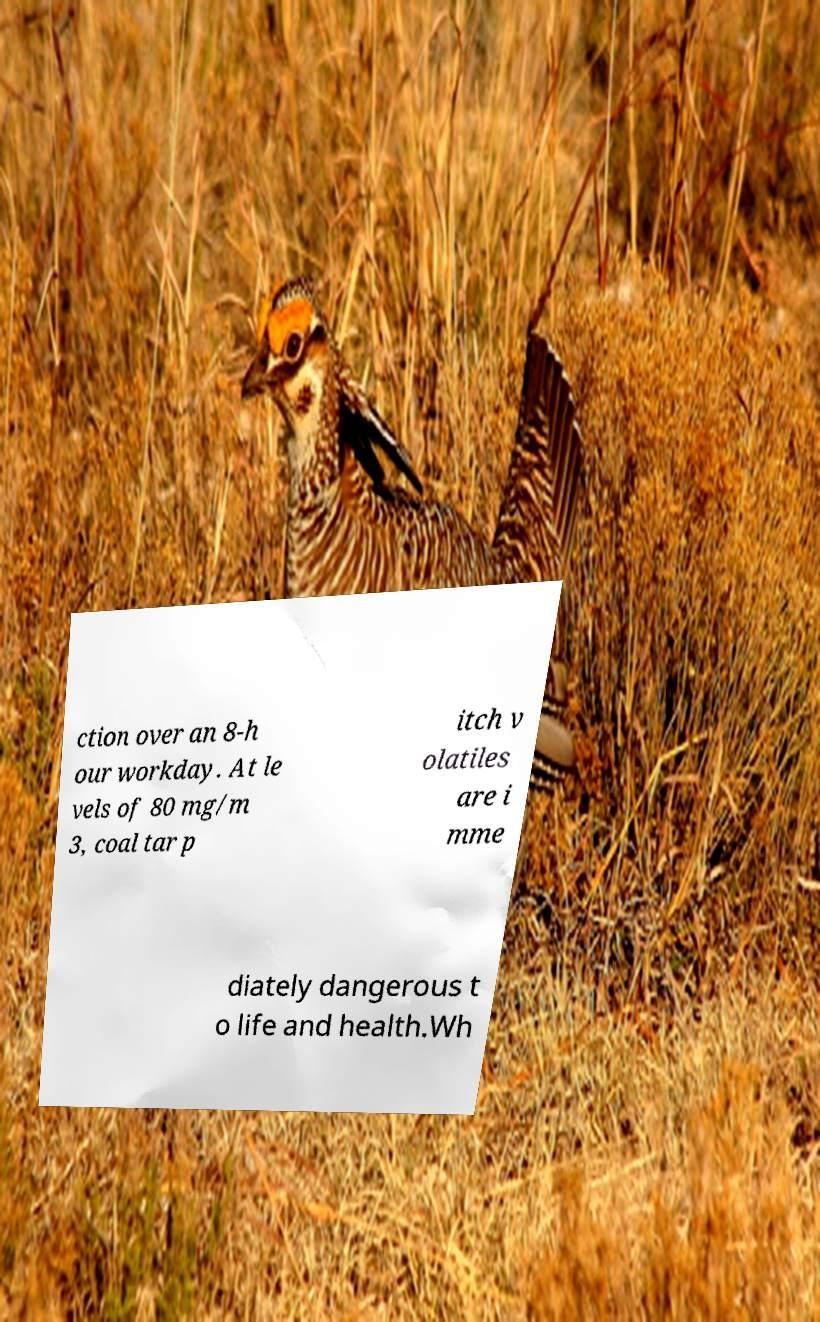Please read and relay the text visible in this image. What does it say? ction over an 8-h our workday. At le vels of 80 mg/m 3, coal tar p itch v olatiles are i mme diately dangerous t o life and health.Wh 